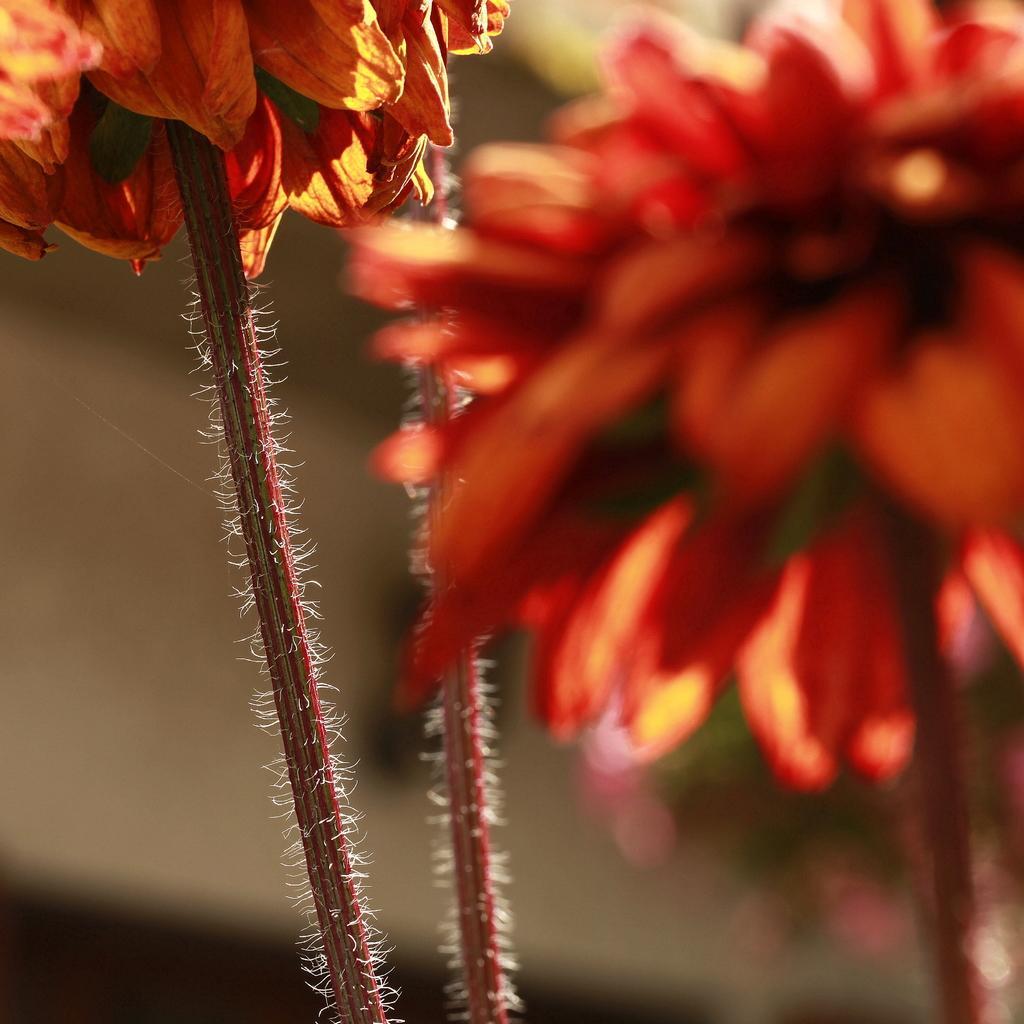Can you describe this image briefly? In this picture we can see stems with flowers and in the background we can see it is blurry. 